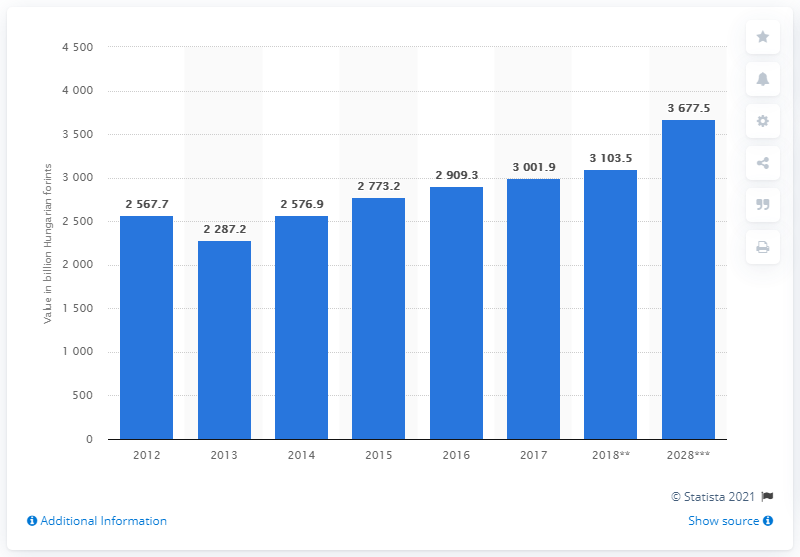Draw attention to some important aspects in this diagram. In 2018, the travel and tourism sector contributed a total of 3103.5 Hungarian forints to the Gross Domestic Product (GDP) of Hungary. 